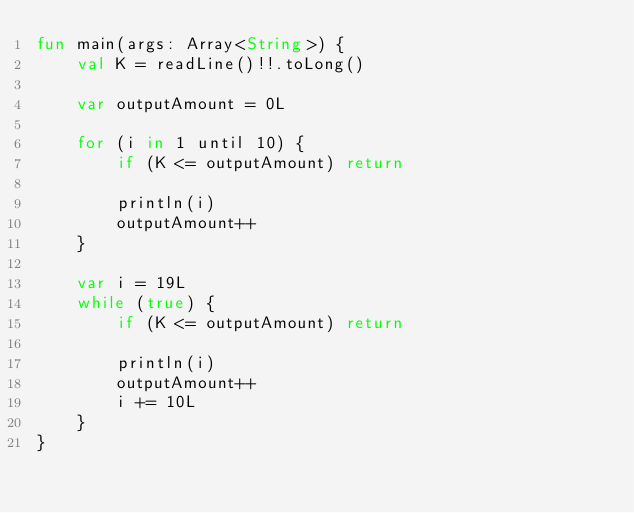<code> <loc_0><loc_0><loc_500><loc_500><_Kotlin_>fun main(args: Array<String>) {
    val K = readLine()!!.toLong()

    var outputAmount = 0L

    for (i in 1 until 10) {
        if (K <= outputAmount) return

        println(i)
        outputAmount++
    }

    var i = 19L
    while (true) {
        if (K <= outputAmount) return

        println(i)
        outputAmount++
        i += 10L
    }
}</code> 